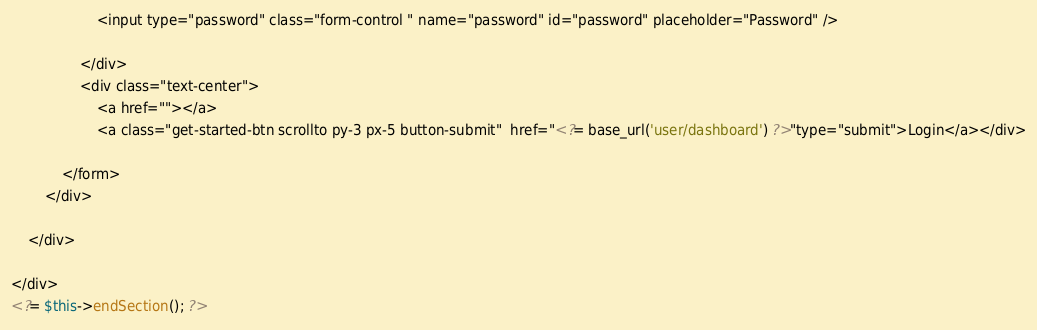<code> <loc_0><loc_0><loc_500><loc_500><_PHP_>                    <input type="password" class="form-control " name="password" id="password" placeholder="Password" />

                </div>
                <div class="text-center">
                    <a href=""></a>
                    <a class="get-started-btn scrollto py-3 px-5 button-submit"  href="<?= base_url('user/dashboard') ?>"type="submit">Login</a></div>
                
            </form>
        </div>

    </div>

</div>
<?= $this->endSection(); ?></code> 